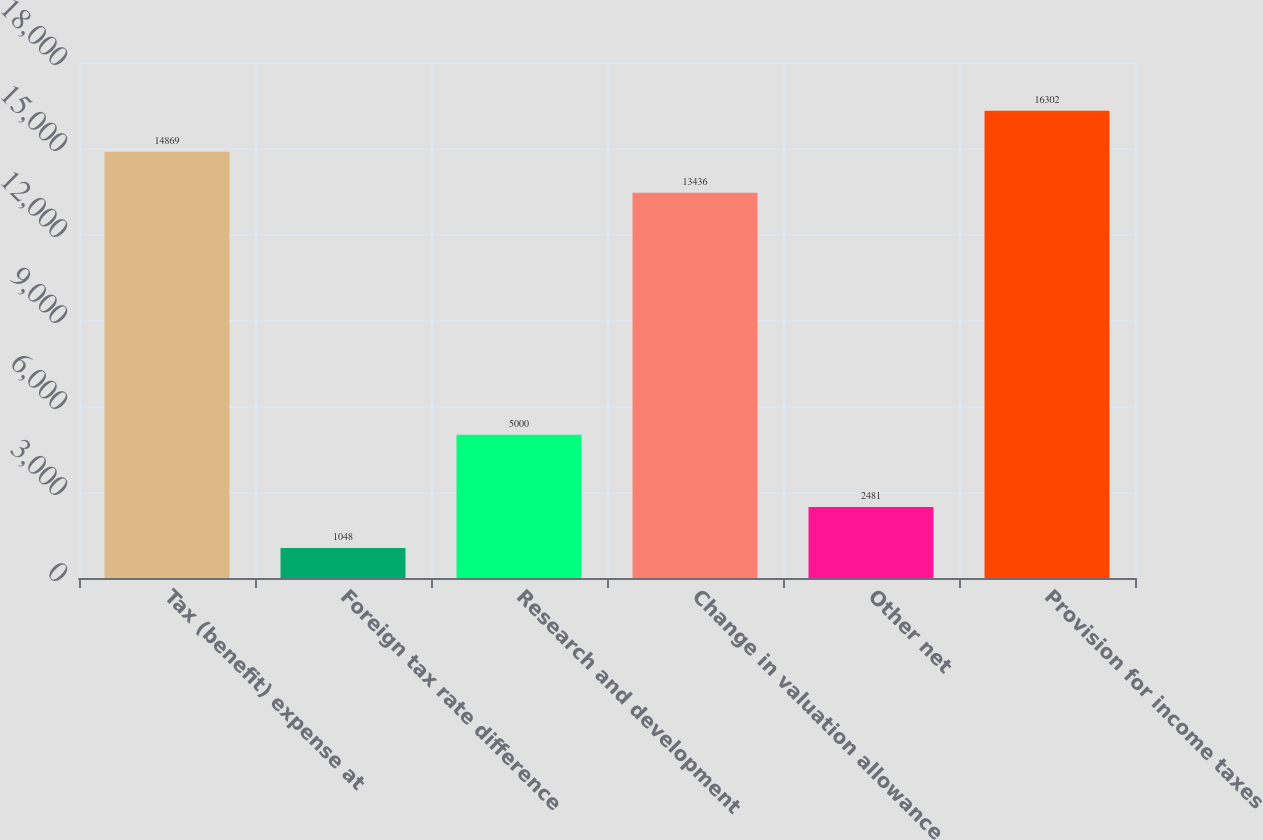<chart> <loc_0><loc_0><loc_500><loc_500><bar_chart><fcel>Tax (benefit) expense at<fcel>Foreign tax rate difference<fcel>Research and development<fcel>Change in valuation allowance<fcel>Other net<fcel>Provision for income taxes<nl><fcel>14869<fcel>1048<fcel>5000<fcel>13436<fcel>2481<fcel>16302<nl></chart> 